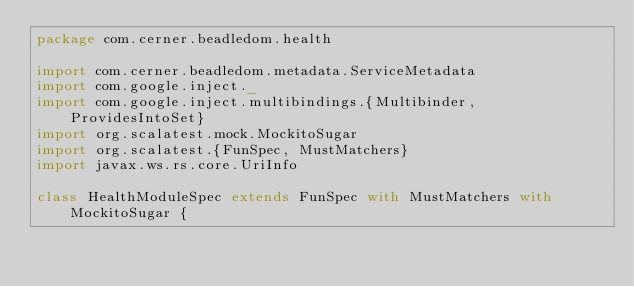<code> <loc_0><loc_0><loc_500><loc_500><_Scala_>package com.cerner.beadledom.health

import com.cerner.beadledom.metadata.ServiceMetadata
import com.google.inject._
import com.google.inject.multibindings.{Multibinder, ProvidesIntoSet}
import org.scalatest.mock.MockitoSugar
import org.scalatest.{FunSpec, MustMatchers}
import javax.ws.rs.core.UriInfo

class HealthModuleSpec extends FunSpec with MustMatchers with MockitoSugar {</code> 